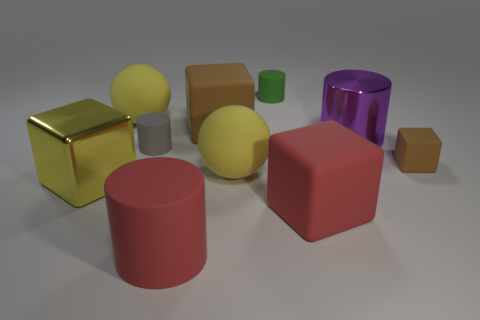Are there any gray matte cylinders? Yes, there is one gray matte cylinder positioned between a gold cube and a yellow sphere. 